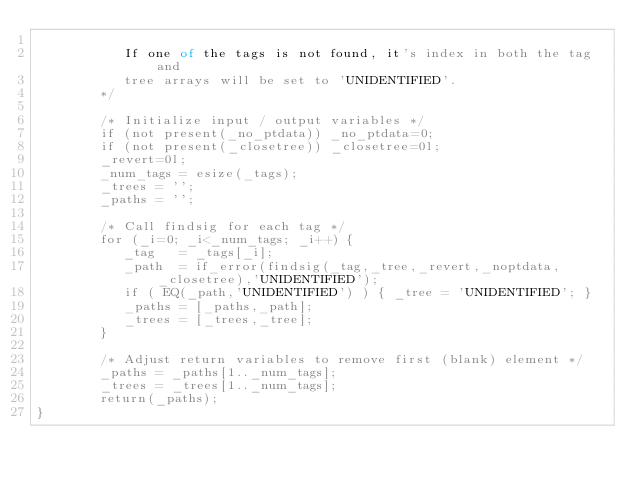<code> <loc_0><loc_0><loc_500><loc_500><_SML_>
           If one of the tags is not found, it's index in both the tag and
           tree arrays will be set to 'UNIDENTIFIED'.
        */ 
      
        /* Initialize input / output variables */ 
        if (not present(_no_ptdata)) _no_ptdata=0;
        if (not present(_closetree)) _closetree=0l;
        _revert=0l;
        _num_tags = esize(_tags);        
        _trees = '';
        _paths = '';

        /* Call findsig for each tag */
        for (_i=0; _i<_num_tags; _i++) { 
           _tag   = _tags[_i];
           _path  = if_error(findsig(_tag,_tree,_revert,_noptdata,_closetree),'UNIDENTIFIED'); 
           if ( EQ(_path,'UNIDENTIFIED') ) { _tree = 'UNIDENTIFIED'; } 
           _paths = [_paths,_path];
           _trees = [_trees,_tree];   
        }

        /* Adjust return variables to remove first (blank) element */
        _paths = _paths[1.._num_tags];
        _trees = _trees[1.._num_tags];
        return(_paths);
}
</code> 